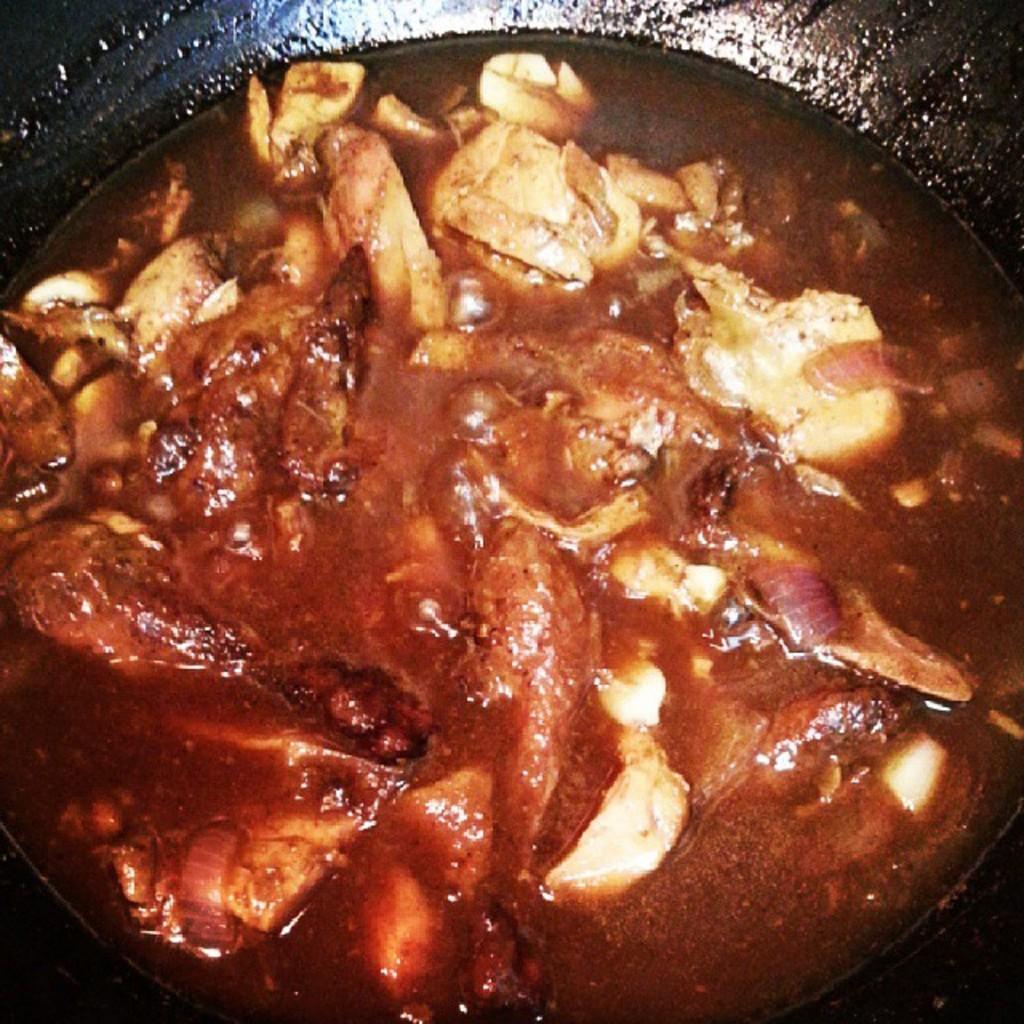Can you describe this image briefly? In this picture we can see chicken curry in the black pan. 